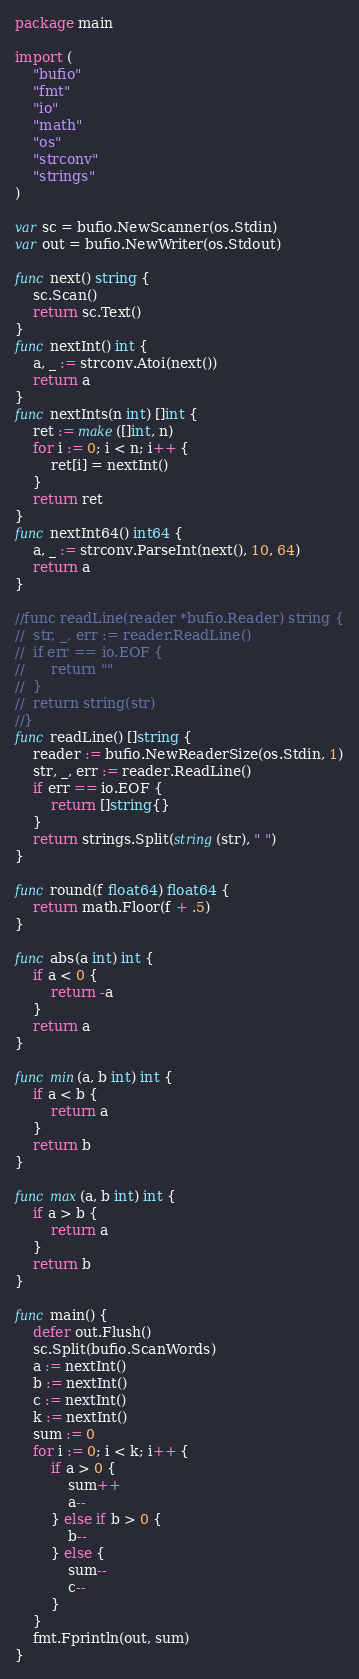Convert code to text. <code><loc_0><loc_0><loc_500><loc_500><_Go_>package main

import (
	"bufio"
	"fmt"
	"io"
	"math"
	"os"
	"strconv"
	"strings"
)

var sc = bufio.NewScanner(os.Stdin)
var out = bufio.NewWriter(os.Stdout)

func next() string {
	sc.Scan()
	return sc.Text()
}
func nextInt() int {
	a, _ := strconv.Atoi(next())
	return a
}
func nextInts(n int) []int {
	ret := make([]int, n)
	for i := 0; i < n; i++ {
		ret[i] = nextInt()
	}
	return ret
}
func nextInt64() int64 {
	a, _ := strconv.ParseInt(next(), 10, 64)
	return a
}

//func readLine(reader *bufio.Reader) string {
//	str, _, err := reader.ReadLine()
//	if err == io.EOF {
//		return ""
//	}
//	return string(str)
//}
func readLine() []string {
	reader := bufio.NewReaderSize(os.Stdin, 1)
	str, _, err := reader.ReadLine()
	if err == io.EOF {
		return []string{}
	}
	return strings.Split(string(str), " ")
}

func round(f float64) float64 {
	return math.Floor(f + .5)
}

func abs(a int) int {
	if a < 0 {
		return -a
	}
	return a
}

func min(a, b int) int {
	if a < b {
		return a
	}
	return b
}

func max(a, b int) int {
	if a > b {
		return a
	}
	return b
}

func main() {
	defer out.Flush()
	sc.Split(bufio.ScanWords)
	a := nextInt()
	b := nextInt()
	c := nextInt()
	k := nextInt()
	sum := 0
	for i := 0; i < k; i++ {
		if a > 0 {
			sum++
			a--
		} else if b > 0 {
			b--
		} else {
			sum--
			c--
		}
	}
	fmt.Fprintln(out, sum)
}
</code> 